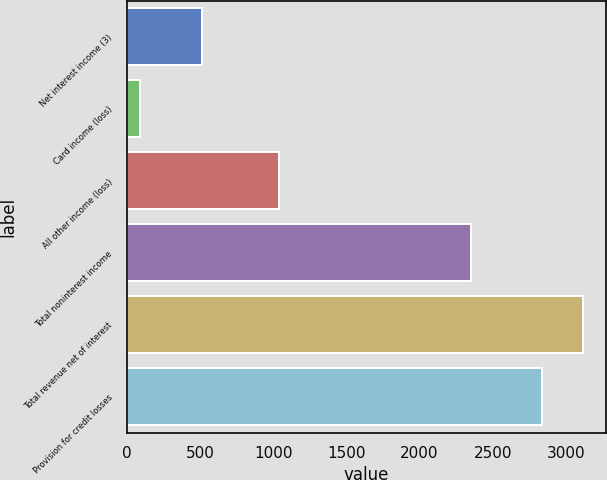Convert chart. <chart><loc_0><loc_0><loc_500><loc_500><bar_chart><fcel>Net interest income (3)<fcel>Card income (loss)<fcel>All other income (loss)<fcel>Total noninterest income<fcel>Total revenue net of interest<fcel>Provision for credit losses<nl><fcel>510<fcel>86<fcel>1040<fcel>2352<fcel>3116.6<fcel>2839<nl></chart> 